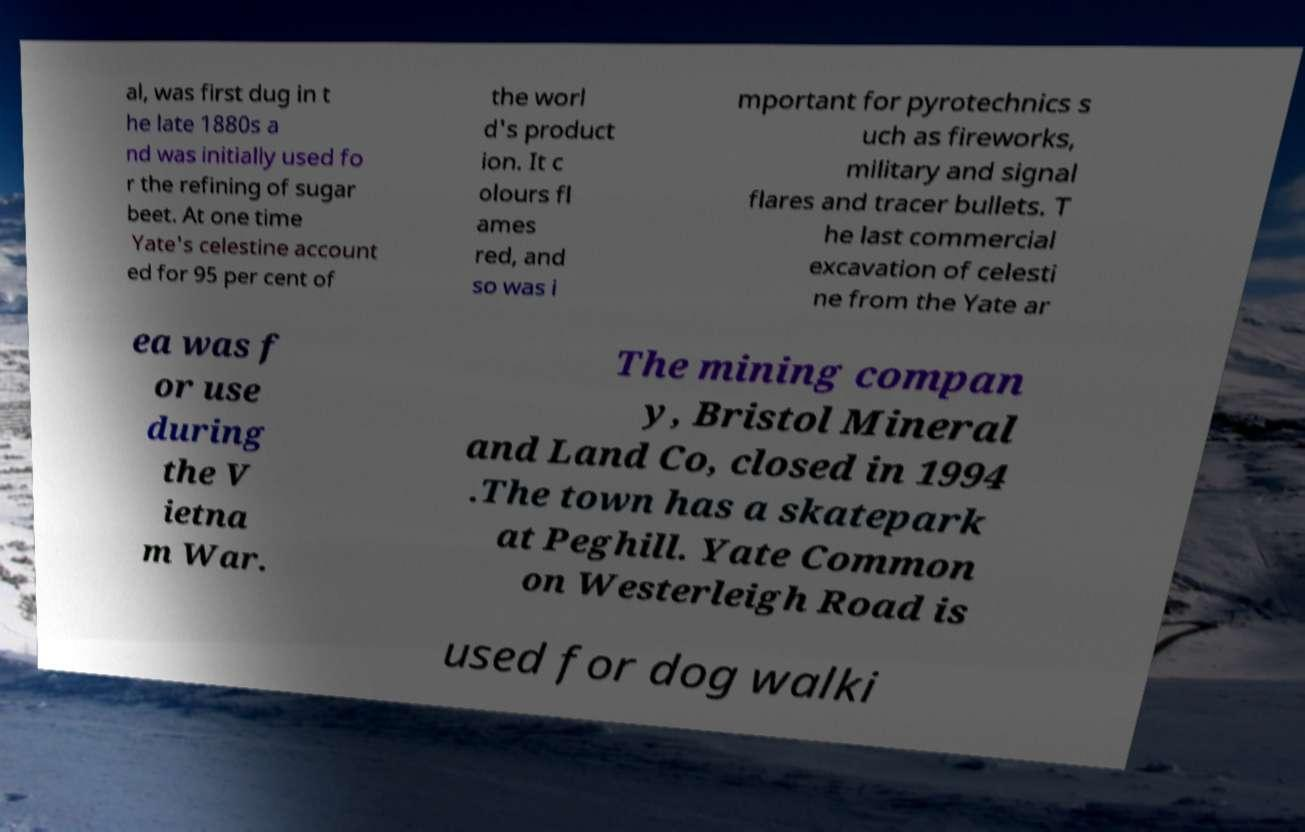Could you extract and type out the text from this image? al, was first dug in t he late 1880s a nd was initially used fo r the refining of sugar beet. At one time Yate's celestine account ed for 95 per cent of the worl d's product ion. It c olours fl ames red, and so was i mportant for pyrotechnics s uch as fireworks, military and signal flares and tracer bullets. T he last commercial excavation of celesti ne from the Yate ar ea was f or use during the V ietna m War. The mining compan y, Bristol Mineral and Land Co, closed in 1994 .The town has a skatepark at Peghill. Yate Common on Westerleigh Road is used for dog walki 